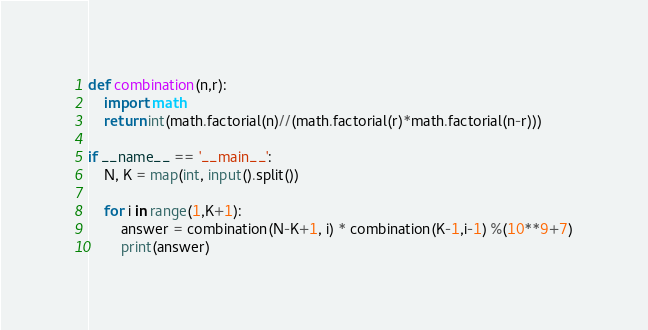Convert code to text. <code><loc_0><loc_0><loc_500><loc_500><_Python_>def combination(n,r):
    import math
    return int(math.factorial(n)//(math.factorial(r)*math.factorial(n-r)))

if __name__ == '__main__':
    N, K = map(int, input().split())

    for i in range(1,K+1):
        answer = combination(N-K+1, i) * combination(K-1,i-1) %(10**9+7)
        print(answer)</code> 